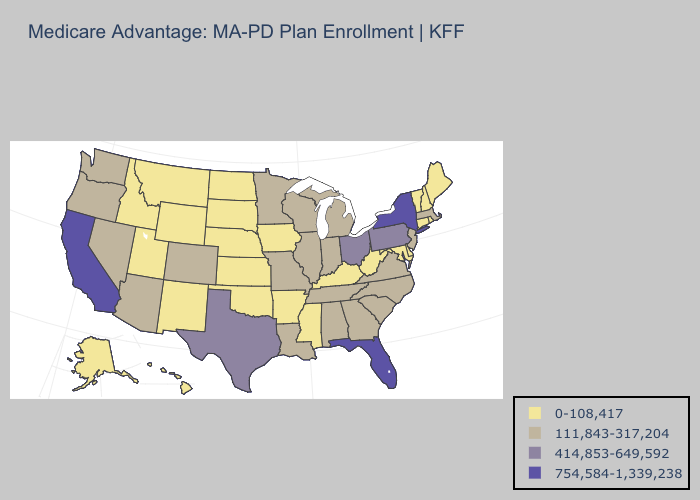Name the states that have a value in the range 111,843-317,204?
Concise answer only. Alabama, Arizona, Colorado, Georgia, Illinois, Indiana, Louisiana, Massachusetts, Michigan, Minnesota, Missouri, North Carolina, New Jersey, Nevada, Oregon, South Carolina, Tennessee, Virginia, Washington, Wisconsin. Which states have the highest value in the USA?
Short answer required. California, Florida, New York. Which states have the lowest value in the USA?
Answer briefly. Alaska, Arkansas, Connecticut, Delaware, Hawaii, Iowa, Idaho, Kansas, Kentucky, Maryland, Maine, Mississippi, Montana, North Dakota, Nebraska, New Hampshire, New Mexico, Oklahoma, Rhode Island, South Dakota, Utah, Vermont, West Virginia, Wyoming. What is the lowest value in states that border Washington?
Quick response, please. 0-108,417. Does South Dakota have the same value as Washington?
Short answer required. No. Among the states that border California , which have the highest value?
Short answer required. Arizona, Nevada, Oregon. What is the highest value in the USA?
Answer briefly. 754,584-1,339,238. What is the highest value in the MidWest ?
Write a very short answer. 414,853-649,592. What is the lowest value in the USA?
Keep it brief. 0-108,417. Does Florida have the highest value in the USA?
Be succinct. Yes. Does California have the highest value in the USA?
Short answer required. Yes. What is the lowest value in the MidWest?
Short answer required. 0-108,417. Name the states that have a value in the range 754,584-1,339,238?
Write a very short answer. California, Florida, New York. Which states have the lowest value in the West?
Give a very brief answer. Alaska, Hawaii, Idaho, Montana, New Mexico, Utah, Wyoming. 